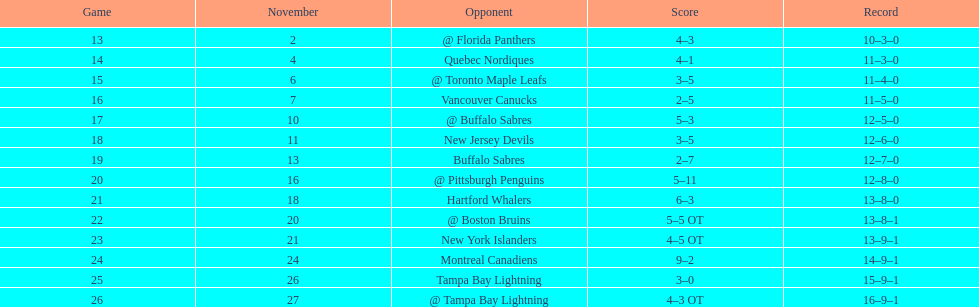Parse the table in full. {'header': ['Game', 'November', 'Opponent', 'Score', 'Record'], 'rows': [['13', '2', '@ Florida Panthers', '4–3', '10–3–0'], ['14', '4', 'Quebec Nordiques', '4–1', '11–3–0'], ['15', '6', '@ Toronto Maple Leafs', '3–5', '11–4–0'], ['16', '7', 'Vancouver Canucks', '2–5', '11–5–0'], ['17', '10', '@ Buffalo Sabres', '5–3', '12–5–0'], ['18', '11', 'New Jersey Devils', '3–5', '12–6–0'], ['19', '13', 'Buffalo Sabres', '2–7', '12–7–0'], ['20', '16', '@ Pittsburgh Penguins', '5–11', '12–8–0'], ['21', '18', 'Hartford Whalers', '6–3', '13–8–0'], ['22', '20', '@ Boston Bruins', '5–5 OT', '13–8–1'], ['23', '21', 'New York Islanders', '4–5 OT', '13–9–1'], ['24', '24', 'Montreal Canadiens', '9–2', '14–9–1'], ['25', '26', 'Tampa Bay Lightning', '3–0', '15–9–1'], ['26', '27', '@ Tampa Bay Lightning', '4–3 OT', '16–9–1']]} Who had the most assists on the 1993-1994 flyers? Mark Recchi. 